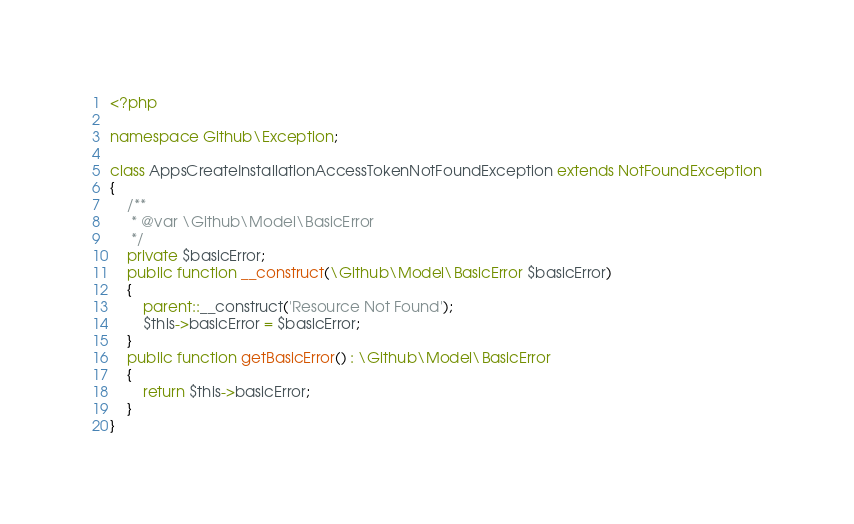<code> <loc_0><loc_0><loc_500><loc_500><_PHP_><?php

namespace Github\Exception;

class AppsCreateInstallationAccessTokenNotFoundException extends NotFoundException
{
    /**
     * @var \Github\Model\BasicError
     */
    private $basicError;
    public function __construct(\Github\Model\BasicError $basicError)
    {
        parent::__construct('Resource Not Found');
        $this->basicError = $basicError;
    }
    public function getBasicError() : \Github\Model\BasicError
    {
        return $this->basicError;
    }
}</code> 